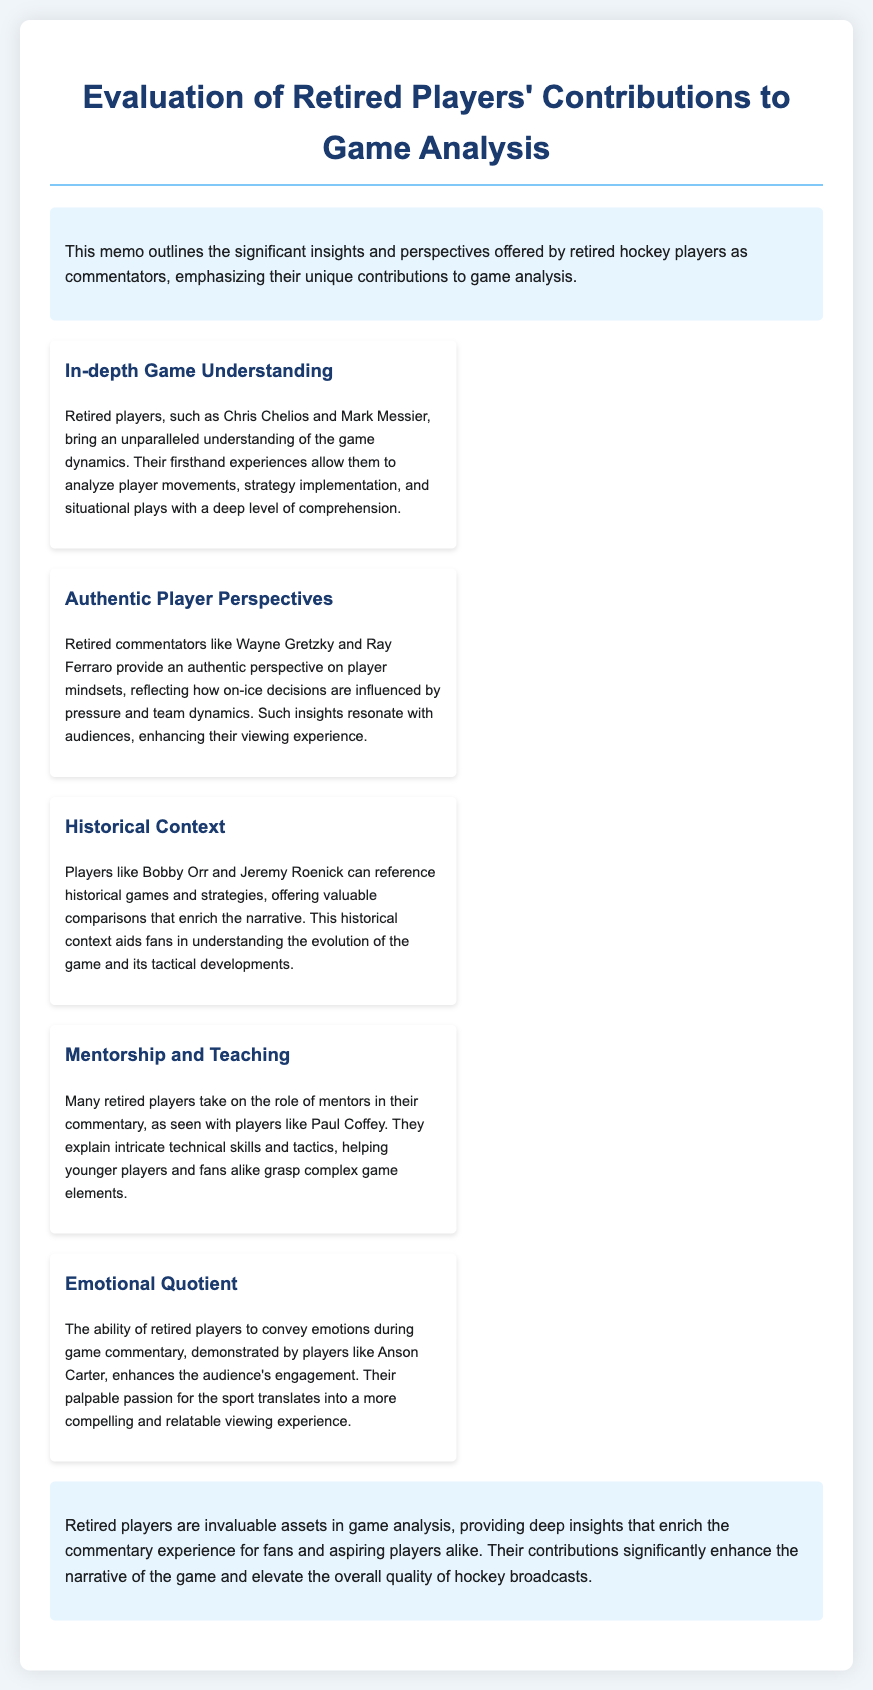What is the title of the memo? The title of the memo is clearly stated at the top, which is "Evaluation of Retired Players' Contributions to Game Analysis."
Answer: Evaluation of Retired Players' Contributions to Game Analysis Who provides an authentic player perspective in commentary? The document mentions Wayne Gretzky and Ray Ferraro as retired commentators offering authentic perspectives on player mindsets.
Answer: Wayne Gretzky and Ray Ferraro What role do many retired players take on in their commentary? The memo highlights that many retired players, such as Paul Coffey, take on the role of mentors, explaining technical skills and tactics.
Answer: Mentors Which player's commentary is mentioned as conveying emotional engagement? The document specifies that Anson Carter is noted for his ability to convey emotions in game commentary, enhancing audience engagement.
Answer: Anson Carter What historical contributions do players like Bobby Orr provide? The memo states that players like Bobby Orr reference historical games and strategies, offering valuable comparisons to enrich the narrative.
Answer: Historical context How do retired players enhance the viewing experience? According to the document, retired players provide deep insights that enrich commentary, significantly enhancing the narrative of the game.
Answer: Deep insights What type of game understanding do retired players like Chris Chelios bring? The document indicates that retired players bring an "in-depth" understanding of game dynamics based on their firsthand experiences.
Answer: In-depth What is stated as a key factor in the contributions of retired players? The memo emphasizes that the contributions of retired players significantly enhance the narrative of the game and elevate broadcast quality.
Answer: Enhance the narrative 